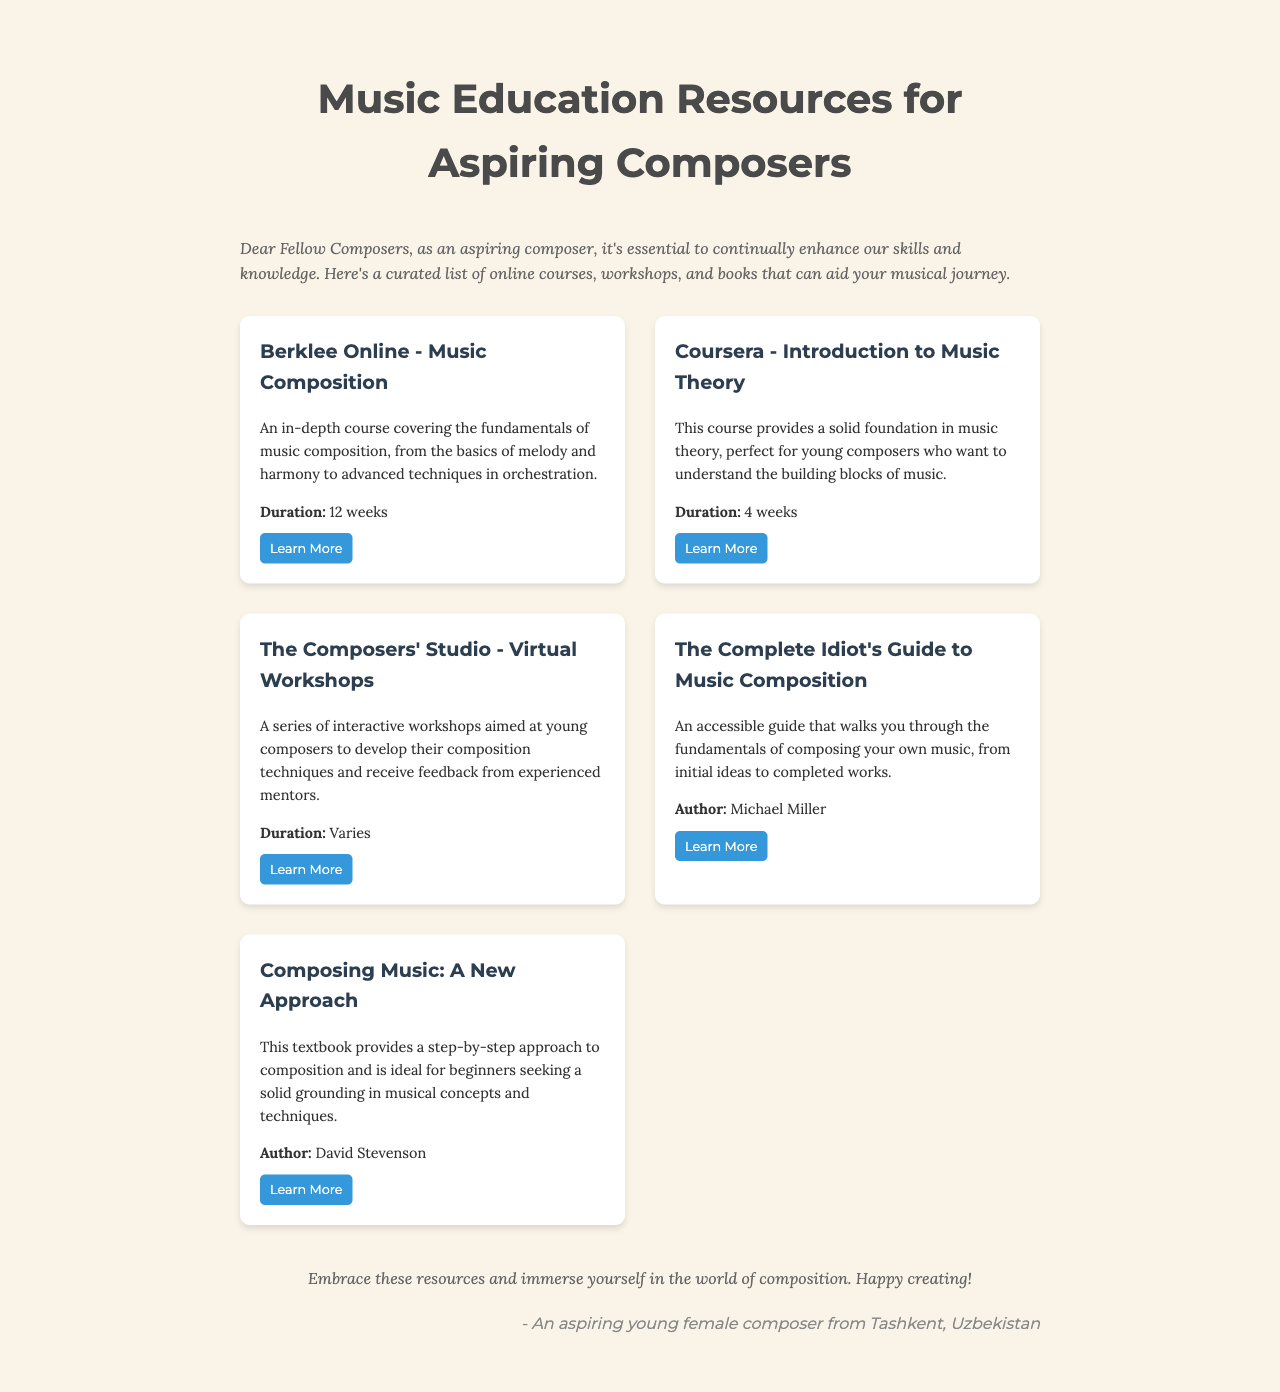What is the title of the newsletter? The title is the main heading displayed prominently at the top of the document.
Answer: Music Education Resources for Aspiring Composers Who is the author of "The Complete Idiot's Guide to Music Composition"? This information is found under the description of the resource and identifies the writer of the book.
Answer: Michael Miller What is the duration of the Berklee Online course? This information specifies the length of the course provided in the resource section.
Answer: 12 weeks What type of workshops does The Composers' Studio offer? This addresses the nature of the workshops provided and highlights their purpose.
Answer: Interactive workshops How many weeks does the Introduction to Music Theory course last? This asks for the specific duration of the course mentioned and found in the document.
Answer: 4 weeks What is the main purpose of the newsletter? The purpose describes the newsletter's objective as stated in the introduction.
Answer: Enhance skills and knowledge Which resource focuses on providing a textbook approach to composition? This question inquires about the specific resource mentioned that is structured as a textbook.
Answer: Composing Music: A New Approach 